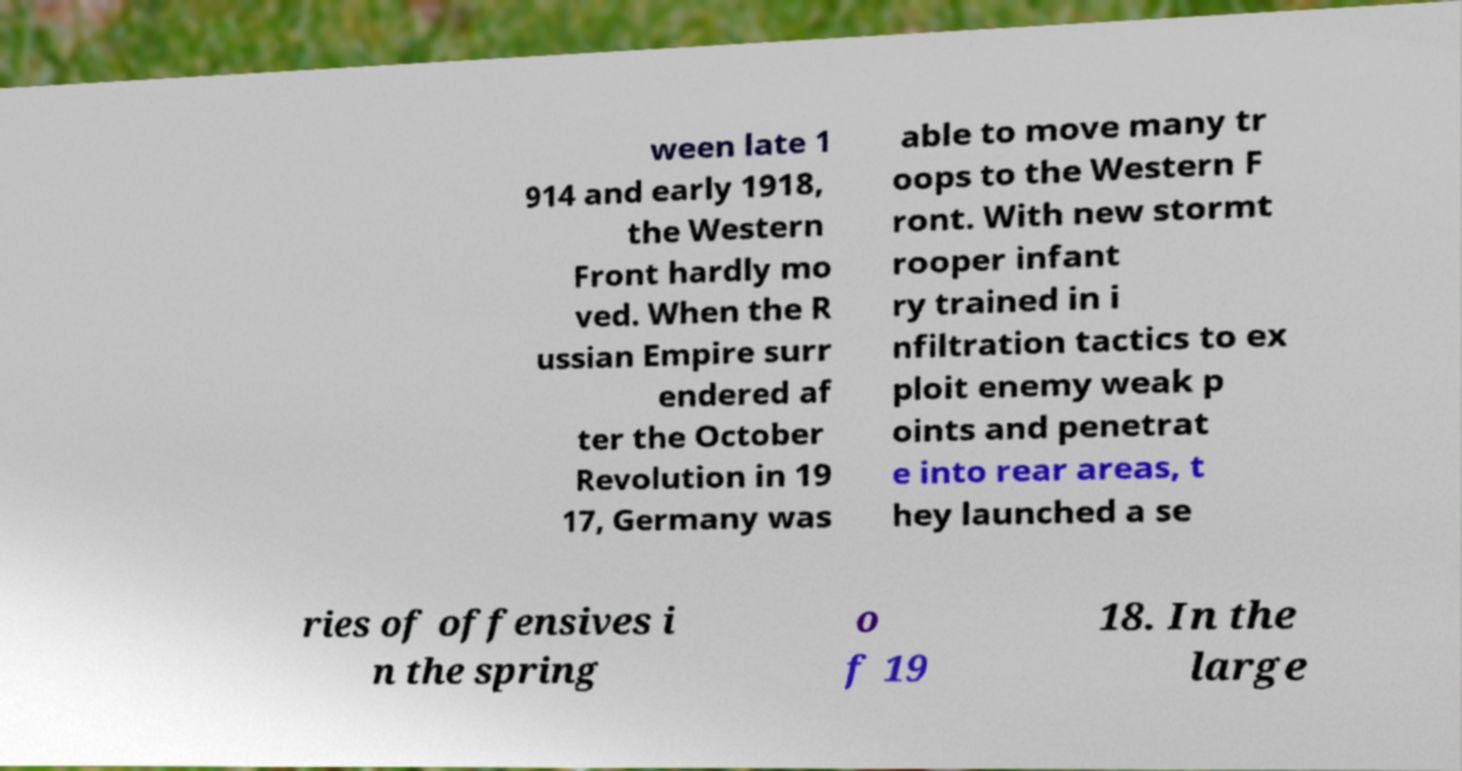There's text embedded in this image that I need extracted. Can you transcribe it verbatim? ween late 1 914 and early 1918, the Western Front hardly mo ved. When the R ussian Empire surr endered af ter the October Revolution in 19 17, Germany was able to move many tr oops to the Western F ront. With new stormt rooper infant ry trained in i nfiltration tactics to ex ploit enemy weak p oints and penetrat e into rear areas, t hey launched a se ries of offensives i n the spring o f 19 18. In the large 